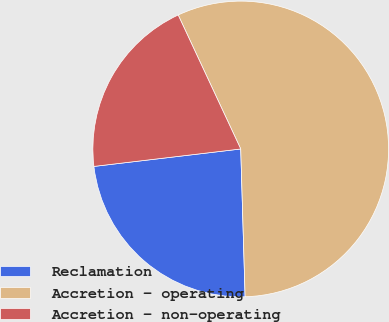Convert chart to OTSL. <chart><loc_0><loc_0><loc_500><loc_500><pie_chart><fcel>Reclamation<fcel>Accretion - operating<fcel>Accretion - non-operating<nl><fcel>23.59%<fcel>56.48%<fcel>19.93%<nl></chart> 